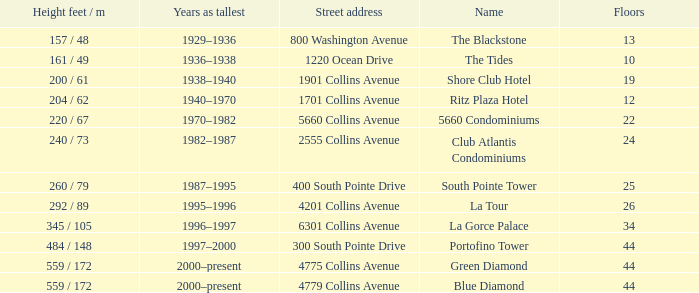How many floors does the Blue Diamond have? 44.0. 